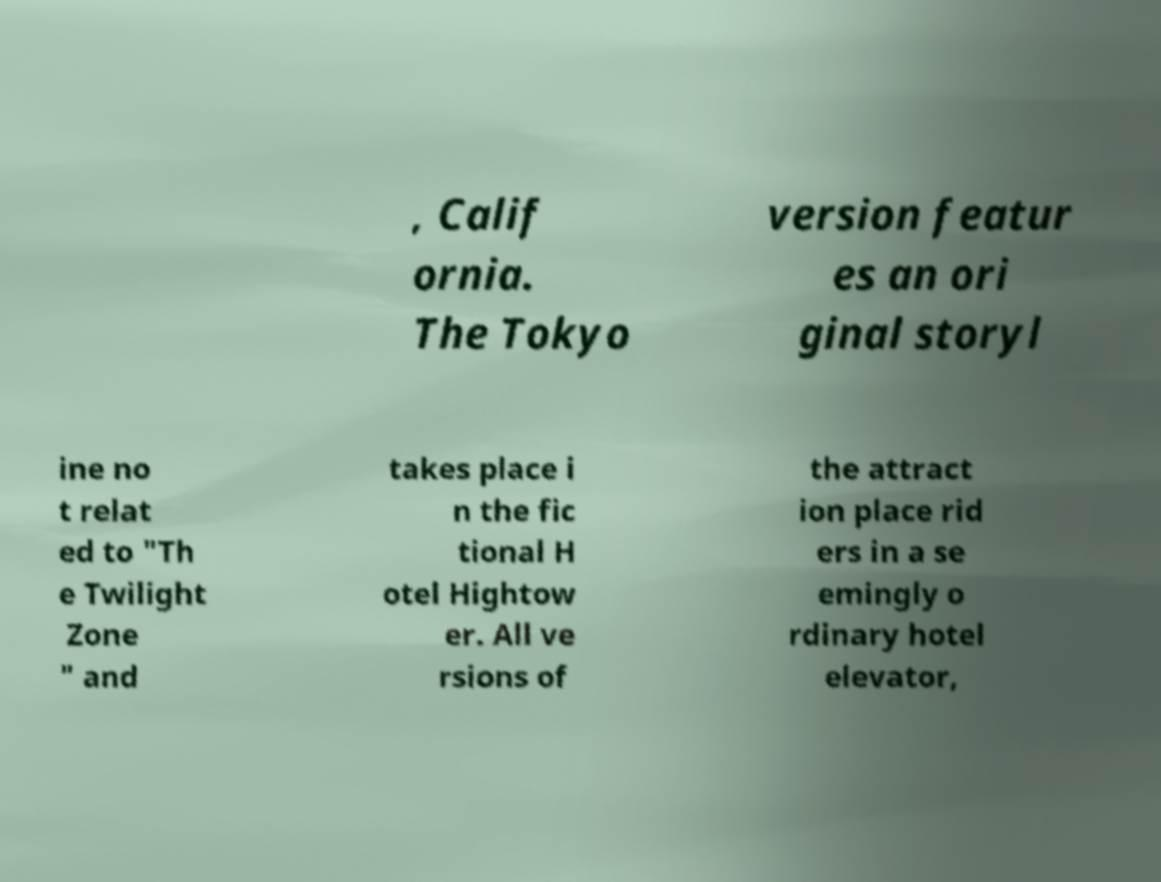There's text embedded in this image that I need extracted. Can you transcribe it verbatim? , Calif ornia. The Tokyo version featur es an ori ginal storyl ine no t relat ed to "Th e Twilight Zone " and takes place i n the fic tional H otel Hightow er. All ve rsions of the attract ion place rid ers in a se emingly o rdinary hotel elevator, 